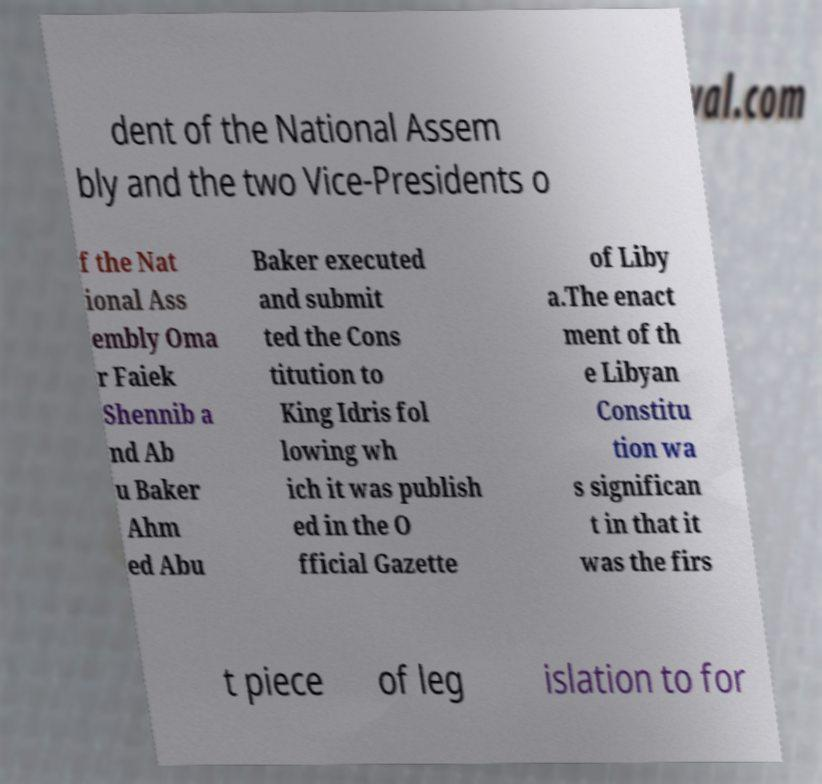Please read and relay the text visible in this image. What does it say? dent of the National Assem bly and the two Vice-Presidents o f the Nat ional Ass embly Oma r Faiek Shennib a nd Ab u Baker Ahm ed Abu Baker executed and submit ted the Cons titution to King Idris fol lowing wh ich it was publish ed in the O fficial Gazette of Liby a.The enact ment of th e Libyan Constitu tion wa s significan t in that it was the firs t piece of leg islation to for 